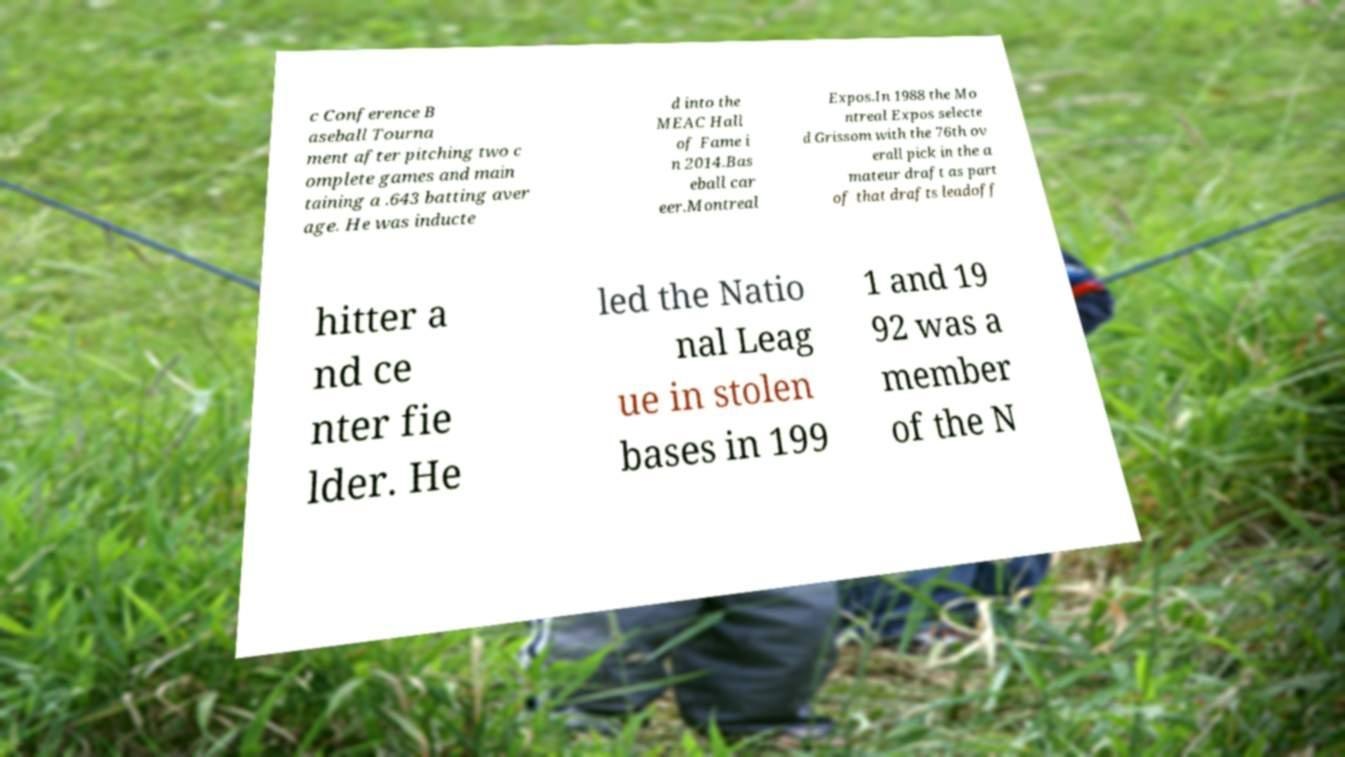Can you accurately transcribe the text from the provided image for me? c Conference B aseball Tourna ment after pitching two c omplete games and main taining a .643 batting aver age. He was inducte d into the MEAC Hall of Fame i n 2014.Bas eball car eer.Montreal Expos.In 1988 the Mo ntreal Expos selecte d Grissom with the 76th ov erall pick in the a mateur draft as part of that drafts leadoff hitter a nd ce nter fie lder. He led the Natio nal Leag ue in stolen bases in 199 1 and 19 92 was a member of the N 